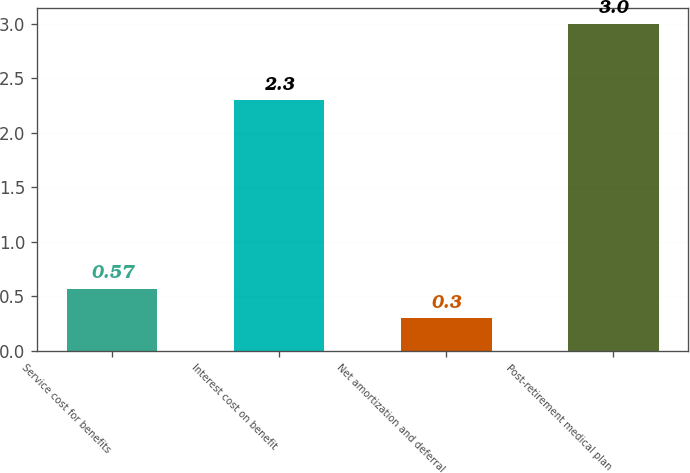Convert chart to OTSL. <chart><loc_0><loc_0><loc_500><loc_500><bar_chart><fcel>Service cost for benefits<fcel>Interest cost on benefit<fcel>Net amortization and deferral<fcel>Post-retirement medical plan<nl><fcel>0.57<fcel>2.3<fcel>0.3<fcel>3<nl></chart> 